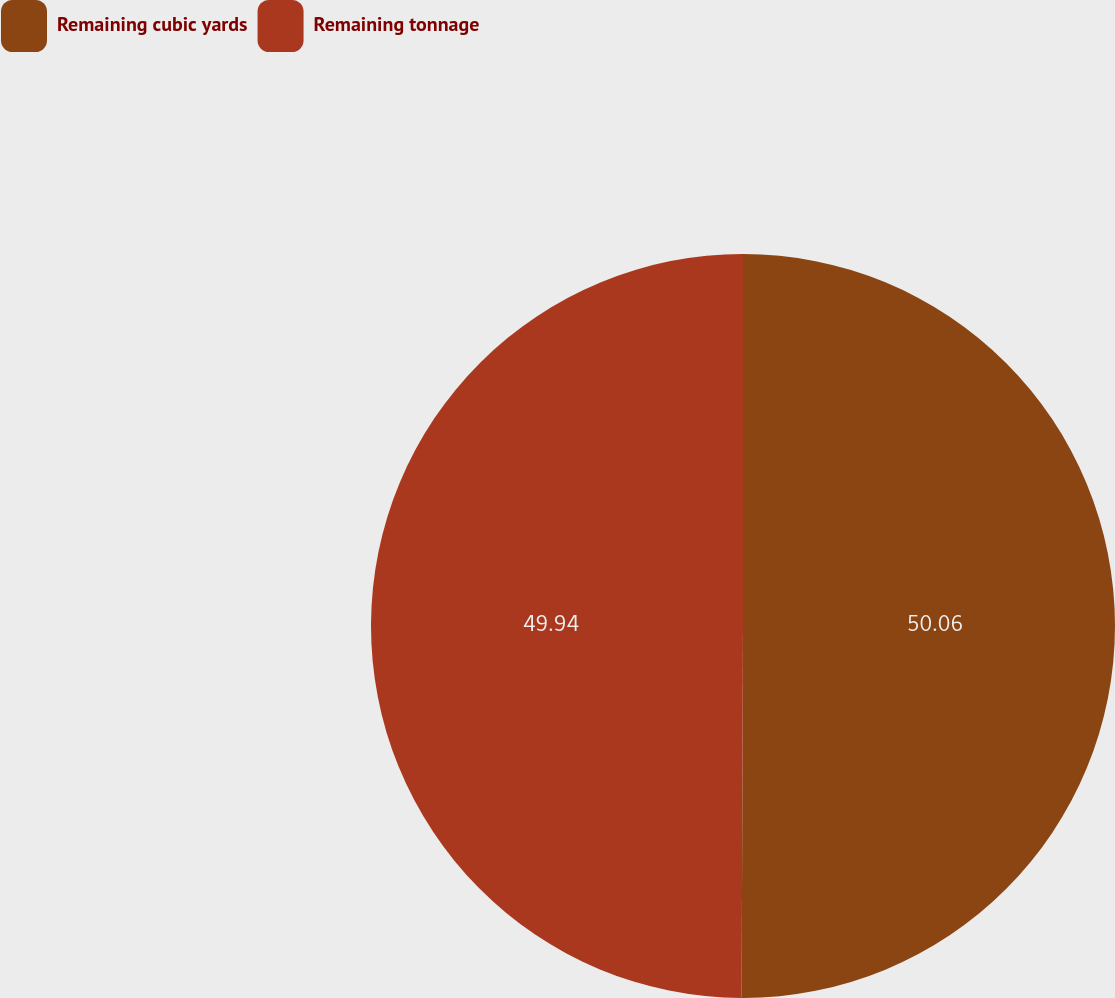Convert chart to OTSL. <chart><loc_0><loc_0><loc_500><loc_500><pie_chart><fcel>Remaining cubic yards<fcel>Remaining tonnage<nl><fcel>50.06%<fcel>49.94%<nl></chart> 